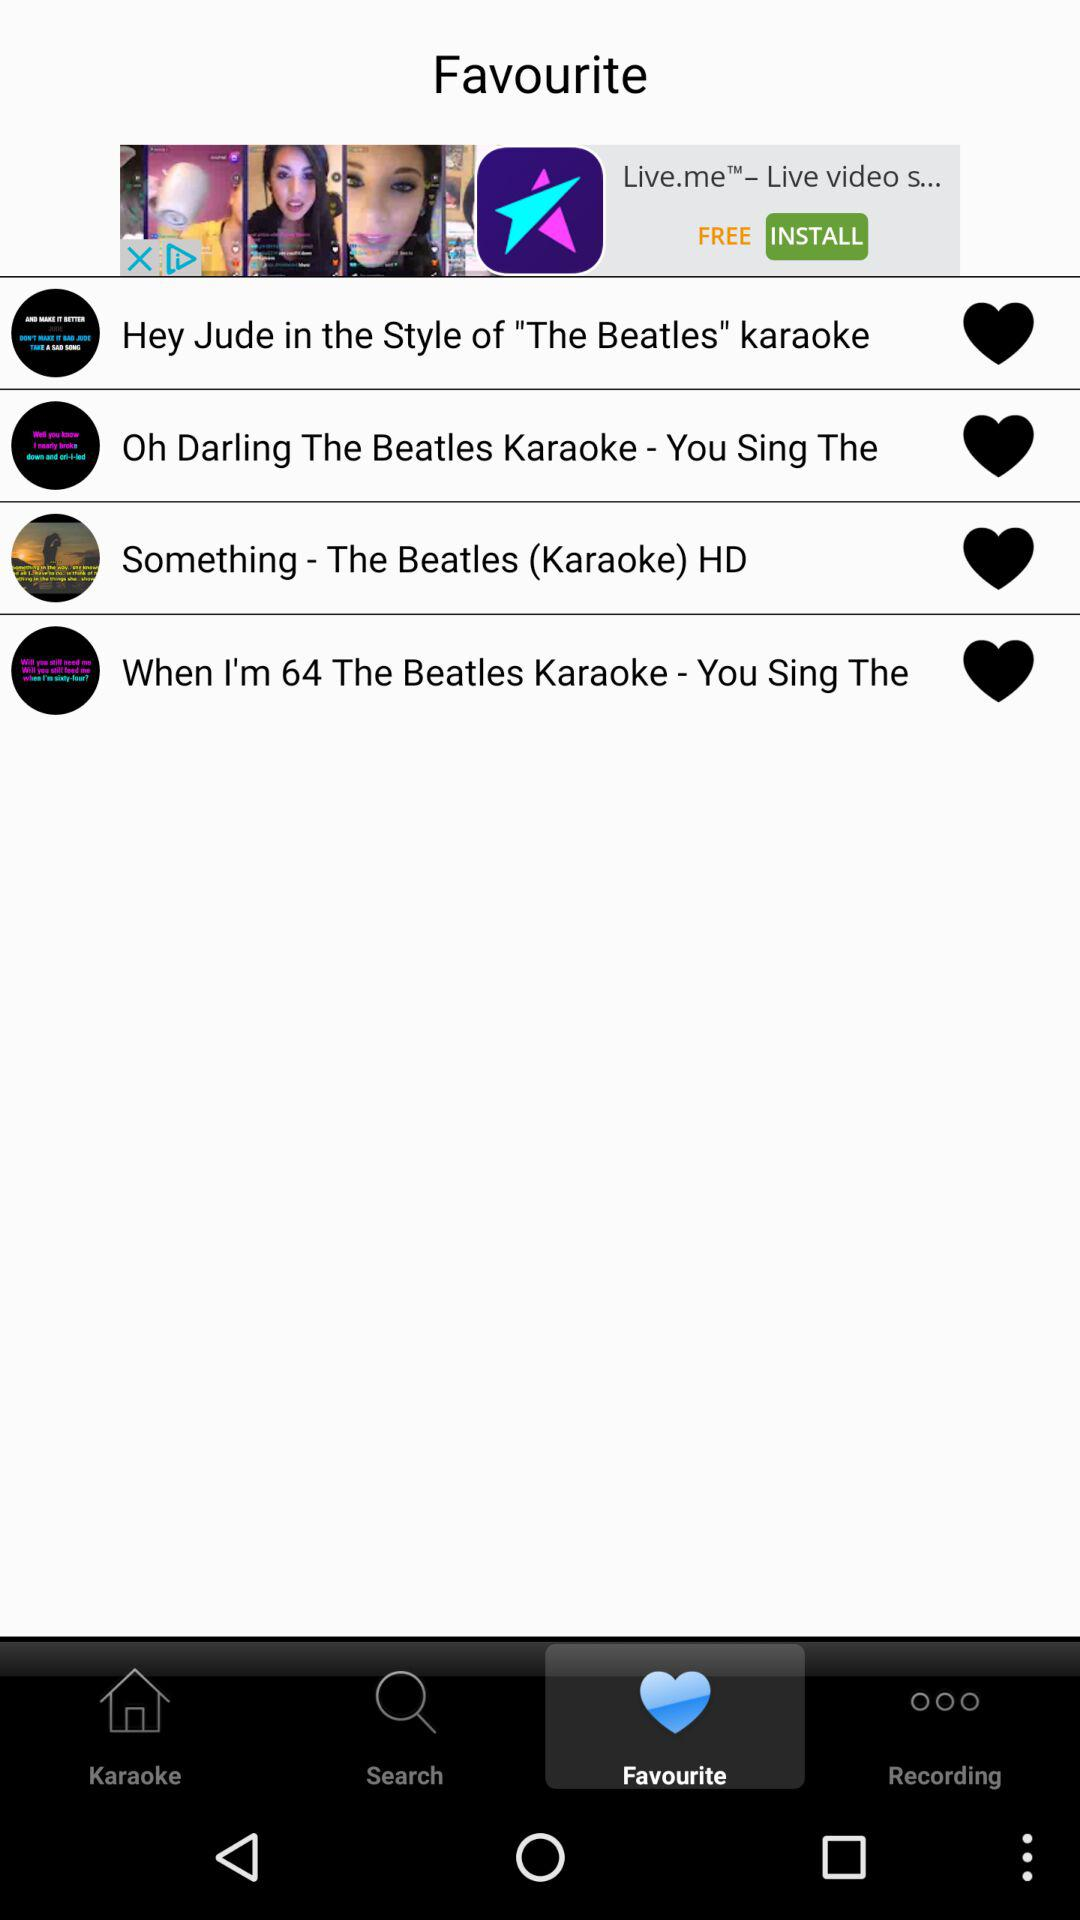Which tab has been selected? The tab that has been selected is "Favourite". 